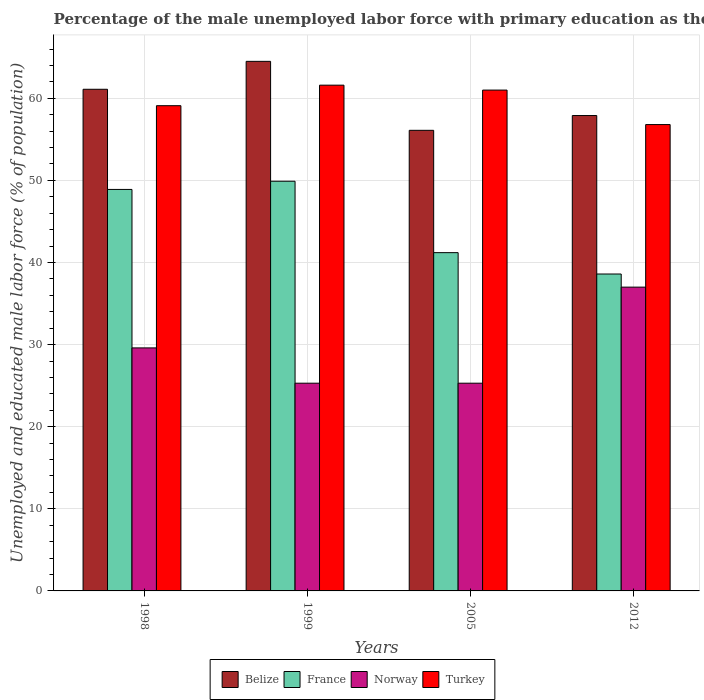How many different coloured bars are there?
Make the answer very short. 4. How many groups of bars are there?
Give a very brief answer. 4. How many bars are there on the 2nd tick from the left?
Your answer should be very brief. 4. How many bars are there on the 4th tick from the right?
Offer a very short reply. 4. What is the percentage of the unemployed male labor force with primary education in France in 2005?
Offer a terse response. 41.2. Across all years, what is the maximum percentage of the unemployed male labor force with primary education in France?
Ensure brevity in your answer.  49.9. Across all years, what is the minimum percentage of the unemployed male labor force with primary education in Belize?
Offer a very short reply. 56.1. In which year was the percentage of the unemployed male labor force with primary education in Norway maximum?
Your answer should be compact. 2012. What is the total percentage of the unemployed male labor force with primary education in Turkey in the graph?
Your response must be concise. 238.5. What is the difference between the percentage of the unemployed male labor force with primary education in France in 1999 and that in 2005?
Offer a very short reply. 8.7. What is the difference between the percentage of the unemployed male labor force with primary education in France in 2005 and the percentage of the unemployed male labor force with primary education in Belize in 1998?
Provide a succinct answer. -19.9. What is the average percentage of the unemployed male labor force with primary education in Norway per year?
Your response must be concise. 29.3. In the year 1998, what is the difference between the percentage of the unemployed male labor force with primary education in Turkey and percentage of the unemployed male labor force with primary education in Norway?
Give a very brief answer. 29.5. What is the ratio of the percentage of the unemployed male labor force with primary education in France in 2005 to that in 2012?
Make the answer very short. 1.07. Is the percentage of the unemployed male labor force with primary education in Norway in 1998 less than that in 2012?
Provide a succinct answer. Yes. Is the difference between the percentage of the unemployed male labor force with primary education in Turkey in 2005 and 2012 greater than the difference between the percentage of the unemployed male labor force with primary education in Norway in 2005 and 2012?
Give a very brief answer. Yes. What is the difference between the highest and the second highest percentage of the unemployed male labor force with primary education in Belize?
Offer a terse response. 3.4. What is the difference between the highest and the lowest percentage of the unemployed male labor force with primary education in France?
Offer a terse response. 11.3. In how many years, is the percentage of the unemployed male labor force with primary education in Turkey greater than the average percentage of the unemployed male labor force with primary education in Turkey taken over all years?
Your response must be concise. 2. Is it the case that in every year, the sum of the percentage of the unemployed male labor force with primary education in France and percentage of the unemployed male labor force with primary education in Norway is greater than the sum of percentage of the unemployed male labor force with primary education in Belize and percentage of the unemployed male labor force with primary education in Turkey?
Make the answer very short. Yes. What does the 4th bar from the right in 1999 represents?
Give a very brief answer. Belize. Is it the case that in every year, the sum of the percentage of the unemployed male labor force with primary education in Norway and percentage of the unemployed male labor force with primary education in Turkey is greater than the percentage of the unemployed male labor force with primary education in Belize?
Your answer should be compact. Yes. How many bars are there?
Offer a terse response. 16. Are the values on the major ticks of Y-axis written in scientific E-notation?
Provide a short and direct response. No. Does the graph contain grids?
Offer a very short reply. Yes. Where does the legend appear in the graph?
Give a very brief answer. Bottom center. What is the title of the graph?
Make the answer very short. Percentage of the male unemployed labor force with primary education as their highest grade. What is the label or title of the X-axis?
Ensure brevity in your answer.  Years. What is the label or title of the Y-axis?
Give a very brief answer. Unemployed and educated male labor force (% of population). What is the Unemployed and educated male labor force (% of population) of Belize in 1998?
Make the answer very short. 61.1. What is the Unemployed and educated male labor force (% of population) in France in 1998?
Offer a terse response. 48.9. What is the Unemployed and educated male labor force (% of population) in Norway in 1998?
Your answer should be very brief. 29.6. What is the Unemployed and educated male labor force (% of population) of Turkey in 1998?
Make the answer very short. 59.1. What is the Unemployed and educated male labor force (% of population) in Belize in 1999?
Provide a succinct answer. 64.5. What is the Unemployed and educated male labor force (% of population) of France in 1999?
Offer a terse response. 49.9. What is the Unemployed and educated male labor force (% of population) in Norway in 1999?
Offer a terse response. 25.3. What is the Unemployed and educated male labor force (% of population) in Turkey in 1999?
Your answer should be very brief. 61.6. What is the Unemployed and educated male labor force (% of population) in Belize in 2005?
Your answer should be very brief. 56.1. What is the Unemployed and educated male labor force (% of population) of France in 2005?
Your answer should be very brief. 41.2. What is the Unemployed and educated male labor force (% of population) of Norway in 2005?
Keep it short and to the point. 25.3. What is the Unemployed and educated male labor force (% of population) of Belize in 2012?
Your answer should be compact. 57.9. What is the Unemployed and educated male labor force (% of population) in France in 2012?
Provide a succinct answer. 38.6. What is the Unemployed and educated male labor force (% of population) of Norway in 2012?
Give a very brief answer. 37. What is the Unemployed and educated male labor force (% of population) of Turkey in 2012?
Keep it short and to the point. 56.8. Across all years, what is the maximum Unemployed and educated male labor force (% of population) of Belize?
Provide a short and direct response. 64.5. Across all years, what is the maximum Unemployed and educated male labor force (% of population) in France?
Offer a terse response. 49.9. Across all years, what is the maximum Unemployed and educated male labor force (% of population) in Turkey?
Offer a very short reply. 61.6. Across all years, what is the minimum Unemployed and educated male labor force (% of population) of Belize?
Give a very brief answer. 56.1. Across all years, what is the minimum Unemployed and educated male labor force (% of population) of France?
Offer a very short reply. 38.6. Across all years, what is the minimum Unemployed and educated male labor force (% of population) of Norway?
Give a very brief answer. 25.3. Across all years, what is the minimum Unemployed and educated male labor force (% of population) of Turkey?
Your answer should be very brief. 56.8. What is the total Unemployed and educated male labor force (% of population) in Belize in the graph?
Your response must be concise. 239.6. What is the total Unemployed and educated male labor force (% of population) in France in the graph?
Offer a terse response. 178.6. What is the total Unemployed and educated male labor force (% of population) of Norway in the graph?
Your answer should be compact. 117.2. What is the total Unemployed and educated male labor force (% of population) of Turkey in the graph?
Make the answer very short. 238.5. What is the difference between the Unemployed and educated male labor force (% of population) of Belize in 1998 and that in 1999?
Ensure brevity in your answer.  -3.4. What is the difference between the Unemployed and educated male labor force (% of population) in Turkey in 1998 and that in 1999?
Give a very brief answer. -2.5. What is the difference between the Unemployed and educated male labor force (% of population) of Belize in 1998 and that in 2005?
Provide a succinct answer. 5. What is the difference between the Unemployed and educated male labor force (% of population) of Belize in 1998 and that in 2012?
Make the answer very short. 3.2. What is the difference between the Unemployed and educated male labor force (% of population) in France in 1998 and that in 2012?
Provide a short and direct response. 10.3. What is the difference between the Unemployed and educated male labor force (% of population) in Norway in 1998 and that in 2012?
Your response must be concise. -7.4. What is the difference between the Unemployed and educated male labor force (% of population) of Turkey in 1998 and that in 2012?
Give a very brief answer. 2.3. What is the difference between the Unemployed and educated male labor force (% of population) of France in 1999 and that in 2005?
Offer a terse response. 8.7. What is the difference between the Unemployed and educated male labor force (% of population) of Norway in 1999 and that in 2005?
Give a very brief answer. 0. What is the difference between the Unemployed and educated male labor force (% of population) in Turkey in 1999 and that in 2005?
Your response must be concise. 0.6. What is the difference between the Unemployed and educated male labor force (% of population) of Turkey in 1999 and that in 2012?
Your response must be concise. 4.8. What is the difference between the Unemployed and educated male labor force (% of population) of Turkey in 2005 and that in 2012?
Your response must be concise. 4.2. What is the difference between the Unemployed and educated male labor force (% of population) of Belize in 1998 and the Unemployed and educated male labor force (% of population) of France in 1999?
Provide a short and direct response. 11.2. What is the difference between the Unemployed and educated male labor force (% of population) of Belize in 1998 and the Unemployed and educated male labor force (% of population) of Norway in 1999?
Keep it short and to the point. 35.8. What is the difference between the Unemployed and educated male labor force (% of population) in Belize in 1998 and the Unemployed and educated male labor force (% of population) in Turkey in 1999?
Your answer should be very brief. -0.5. What is the difference between the Unemployed and educated male labor force (% of population) in France in 1998 and the Unemployed and educated male labor force (% of population) in Norway in 1999?
Provide a short and direct response. 23.6. What is the difference between the Unemployed and educated male labor force (% of population) in Norway in 1998 and the Unemployed and educated male labor force (% of population) in Turkey in 1999?
Make the answer very short. -32. What is the difference between the Unemployed and educated male labor force (% of population) of Belize in 1998 and the Unemployed and educated male labor force (% of population) of France in 2005?
Keep it short and to the point. 19.9. What is the difference between the Unemployed and educated male labor force (% of population) of Belize in 1998 and the Unemployed and educated male labor force (% of population) of Norway in 2005?
Your response must be concise. 35.8. What is the difference between the Unemployed and educated male labor force (% of population) of Belize in 1998 and the Unemployed and educated male labor force (% of population) of Turkey in 2005?
Keep it short and to the point. 0.1. What is the difference between the Unemployed and educated male labor force (% of population) of France in 1998 and the Unemployed and educated male labor force (% of population) of Norway in 2005?
Ensure brevity in your answer.  23.6. What is the difference between the Unemployed and educated male labor force (% of population) in France in 1998 and the Unemployed and educated male labor force (% of population) in Turkey in 2005?
Make the answer very short. -12.1. What is the difference between the Unemployed and educated male labor force (% of population) in Norway in 1998 and the Unemployed and educated male labor force (% of population) in Turkey in 2005?
Your answer should be compact. -31.4. What is the difference between the Unemployed and educated male labor force (% of population) in Belize in 1998 and the Unemployed and educated male labor force (% of population) in France in 2012?
Keep it short and to the point. 22.5. What is the difference between the Unemployed and educated male labor force (% of population) of Belize in 1998 and the Unemployed and educated male labor force (% of population) of Norway in 2012?
Your response must be concise. 24.1. What is the difference between the Unemployed and educated male labor force (% of population) in Belize in 1998 and the Unemployed and educated male labor force (% of population) in Turkey in 2012?
Keep it short and to the point. 4.3. What is the difference between the Unemployed and educated male labor force (% of population) in France in 1998 and the Unemployed and educated male labor force (% of population) in Norway in 2012?
Give a very brief answer. 11.9. What is the difference between the Unemployed and educated male labor force (% of population) in Norway in 1998 and the Unemployed and educated male labor force (% of population) in Turkey in 2012?
Keep it short and to the point. -27.2. What is the difference between the Unemployed and educated male labor force (% of population) in Belize in 1999 and the Unemployed and educated male labor force (% of population) in France in 2005?
Your answer should be very brief. 23.3. What is the difference between the Unemployed and educated male labor force (% of population) of Belize in 1999 and the Unemployed and educated male labor force (% of population) of Norway in 2005?
Your answer should be very brief. 39.2. What is the difference between the Unemployed and educated male labor force (% of population) in France in 1999 and the Unemployed and educated male labor force (% of population) in Norway in 2005?
Offer a terse response. 24.6. What is the difference between the Unemployed and educated male labor force (% of population) of Norway in 1999 and the Unemployed and educated male labor force (% of population) of Turkey in 2005?
Offer a very short reply. -35.7. What is the difference between the Unemployed and educated male labor force (% of population) in Belize in 1999 and the Unemployed and educated male labor force (% of population) in France in 2012?
Provide a succinct answer. 25.9. What is the difference between the Unemployed and educated male labor force (% of population) in Belize in 1999 and the Unemployed and educated male labor force (% of population) in Norway in 2012?
Provide a succinct answer. 27.5. What is the difference between the Unemployed and educated male labor force (% of population) in France in 1999 and the Unemployed and educated male labor force (% of population) in Norway in 2012?
Provide a short and direct response. 12.9. What is the difference between the Unemployed and educated male labor force (% of population) in France in 1999 and the Unemployed and educated male labor force (% of population) in Turkey in 2012?
Your response must be concise. -6.9. What is the difference between the Unemployed and educated male labor force (% of population) of Norway in 1999 and the Unemployed and educated male labor force (% of population) of Turkey in 2012?
Your response must be concise. -31.5. What is the difference between the Unemployed and educated male labor force (% of population) in Belize in 2005 and the Unemployed and educated male labor force (% of population) in France in 2012?
Your answer should be very brief. 17.5. What is the difference between the Unemployed and educated male labor force (% of population) in Belize in 2005 and the Unemployed and educated male labor force (% of population) in Norway in 2012?
Your response must be concise. 19.1. What is the difference between the Unemployed and educated male labor force (% of population) in Belize in 2005 and the Unemployed and educated male labor force (% of population) in Turkey in 2012?
Make the answer very short. -0.7. What is the difference between the Unemployed and educated male labor force (% of population) in France in 2005 and the Unemployed and educated male labor force (% of population) in Norway in 2012?
Provide a short and direct response. 4.2. What is the difference between the Unemployed and educated male labor force (% of population) in France in 2005 and the Unemployed and educated male labor force (% of population) in Turkey in 2012?
Ensure brevity in your answer.  -15.6. What is the difference between the Unemployed and educated male labor force (% of population) in Norway in 2005 and the Unemployed and educated male labor force (% of population) in Turkey in 2012?
Your answer should be compact. -31.5. What is the average Unemployed and educated male labor force (% of population) in Belize per year?
Provide a short and direct response. 59.9. What is the average Unemployed and educated male labor force (% of population) of France per year?
Make the answer very short. 44.65. What is the average Unemployed and educated male labor force (% of population) of Norway per year?
Ensure brevity in your answer.  29.3. What is the average Unemployed and educated male labor force (% of population) in Turkey per year?
Give a very brief answer. 59.62. In the year 1998, what is the difference between the Unemployed and educated male labor force (% of population) in Belize and Unemployed and educated male labor force (% of population) in Norway?
Your answer should be very brief. 31.5. In the year 1998, what is the difference between the Unemployed and educated male labor force (% of population) of Belize and Unemployed and educated male labor force (% of population) of Turkey?
Keep it short and to the point. 2. In the year 1998, what is the difference between the Unemployed and educated male labor force (% of population) of France and Unemployed and educated male labor force (% of population) of Norway?
Your response must be concise. 19.3. In the year 1998, what is the difference between the Unemployed and educated male labor force (% of population) of Norway and Unemployed and educated male labor force (% of population) of Turkey?
Offer a terse response. -29.5. In the year 1999, what is the difference between the Unemployed and educated male labor force (% of population) of Belize and Unemployed and educated male labor force (% of population) of France?
Provide a succinct answer. 14.6. In the year 1999, what is the difference between the Unemployed and educated male labor force (% of population) in Belize and Unemployed and educated male labor force (% of population) in Norway?
Give a very brief answer. 39.2. In the year 1999, what is the difference between the Unemployed and educated male labor force (% of population) in Belize and Unemployed and educated male labor force (% of population) in Turkey?
Your response must be concise. 2.9. In the year 1999, what is the difference between the Unemployed and educated male labor force (% of population) of France and Unemployed and educated male labor force (% of population) of Norway?
Your answer should be compact. 24.6. In the year 1999, what is the difference between the Unemployed and educated male labor force (% of population) in Norway and Unemployed and educated male labor force (% of population) in Turkey?
Offer a terse response. -36.3. In the year 2005, what is the difference between the Unemployed and educated male labor force (% of population) in Belize and Unemployed and educated male labor force (% of population) in France?
Offer a very short reply. 14.9. In the year 2005, what is the difference between the Unemployed and educated male labor force (% of population) of Belize and Unemployed and educated male labor force (% of population) of Norway?
Provide a succinct answer. 30.8. In the year 2005, what is the difference between the Unemployed and educated male labor force (% of population) of France and Unemployed and educated male labor force (% of population) of Turkey?
Provide a short and direct response. -19.8. In the year 2005, what is the difference between the Unemployed and educated male labor force (% of population) in Norway and Unemployed and educated male labor force (% of population) in Turkey?
Keep it short and to the point. -35.7. In the year 2012, what is the difference between the Unemployed and educated male labor force (% of population) in Belize and Unemployed and educated male labor force (% of population) in France?
Your response must be concise. 19.3. In the year 2012, what is the difference between the Unemployed and educated male labor force (% of population) of Belize and Unemployed and educated male labor force (% of population) of Norway?
Your response must be concise. 20.9. In the year 2012, what is the difference between the Unemployed and educated male labor force (% of population) in Belize and Unemployed and educated male labor force (% of population) in Turkey?
Keep it short and to the point. 1.1. In the year 2012, what is the difference between the Unemployed and educated male labor force (% of population) of France and Unemployed and educated male labor force (% of population) of Turkey?
Make the answer very short. -18.2. In the year 2012, what is the difference between the Unemployed and educated male labor force (% of population) of Norway and Unemployed and educated male labor force (% of population) of Turkey?
Your answer should be very brief. -19.8. What is the ratio of the Unemployed and educated male labor force (% of population) of Belize in 1998 to that in 1999?
Keep it short and to the point. 0.95. What is the ratio of the Unemployed and educated male labor force (% of population) of Norway in 1998 to that in 1999?
Give a very brief answer. 1.17. What is the ratio of the Unemployed and educated male labor force (% of population) of Turkey in 1998 to that in 1999?
Your answer should be compact. 0.96. What is the ratio of the Unemployed and educated male labor force (% of population) of Belize in 1998 to that in 2005?
Keep it short and to the point. 1.09. What is the ratio of the Unemployed and educated male labor force (% of population) in France in 1998 to that in 2005?
Your response must be concise. 1.19. What is the ratio of the Unemployed and educated male labor force (% of population) in Norway in 1998 to that in 2005?
Offer a very short reply. 1.17. What is the ratio of the Unemployed and educated male labor force (% of population) in Turkey in 1998 to that in 2005?
Ensure brevity in your answer.  0.97. What is the ratio of the Unemployed and educated male labor force (% of population) of Belize in 1998 to that in 2012?
Your response must be concise. 1.06. What is the ratio of the Unemployed and educated male labor force (% of population) of France in 1998 to that in 2012?
Offer a very short reply. 1.27. What is the ratio of the Unemployed and educated male labor force (% of population) of Turkey in 1998 to that in 2012?
Offer a terse response. 1.04. What is the ratio of the Unemployed and educated male labor force (% of population) of Belize in 1999 to that in 2005?
Ensure brevity in your answer.  1.15. What is the ratio of the Unemployed and educated male labor force (% of population) of France in 1999 to that in 2005?
Offer a very short reply. 1.21. What is the ratio of the Unemployed and educated male labor force (% of population) of Norway in 1999 to that in 2005?
Your answer should be compact. 1. What is the ratio of the Unemployed and educated male labor force (% of population) of Turkey in 1999 to that in 2005?
Your answer should be very brief. 1.01. What is the ratio of the Unemployed and educated male labor force (% of population) in Belize in 1999 to that in 2012?
Offer a very short reply. 1.11. What is the ratio of the Unemployed and educated male labor force (% of population) of France in 1999 to that in 2012?
Offer a very short reply. 1.29. What is the ratio of the Unemployed and educated male labor force (% of population) of Norway in 1999 to that in 2012?
Ensure brevity in your answer.  0.68. What is the ratio of the Unemployed and educated male labor force (% of population) in Turkey in 1999 to that in 2012?
Give a very brief answer. 1.08. What is the ratio of the Unemployed and educated male labor force (% of population) of Belize in 2005 to that in 2012?
Make the answer very short. 0.97. What is the ratio of the Unemployed and educated male labor force (% of population) of France in 2005 to that in 2012?
Your response must be concise. 1.07. What is the ratio of the Unemployed and educated male labor force (% of population) of Norway in 2005 to that in 2012?
Make the answer very short. 0.68. What is the ratio of the Unemployed and educated male labor force (% of population) in Turkey in 2005 to that in 2012?
Make the answer very short. 1.07. What is the difference between the highest and the lowest Unemployed and educated male labor force (% of population) in France?
Your answer should be compact. 11.3. 